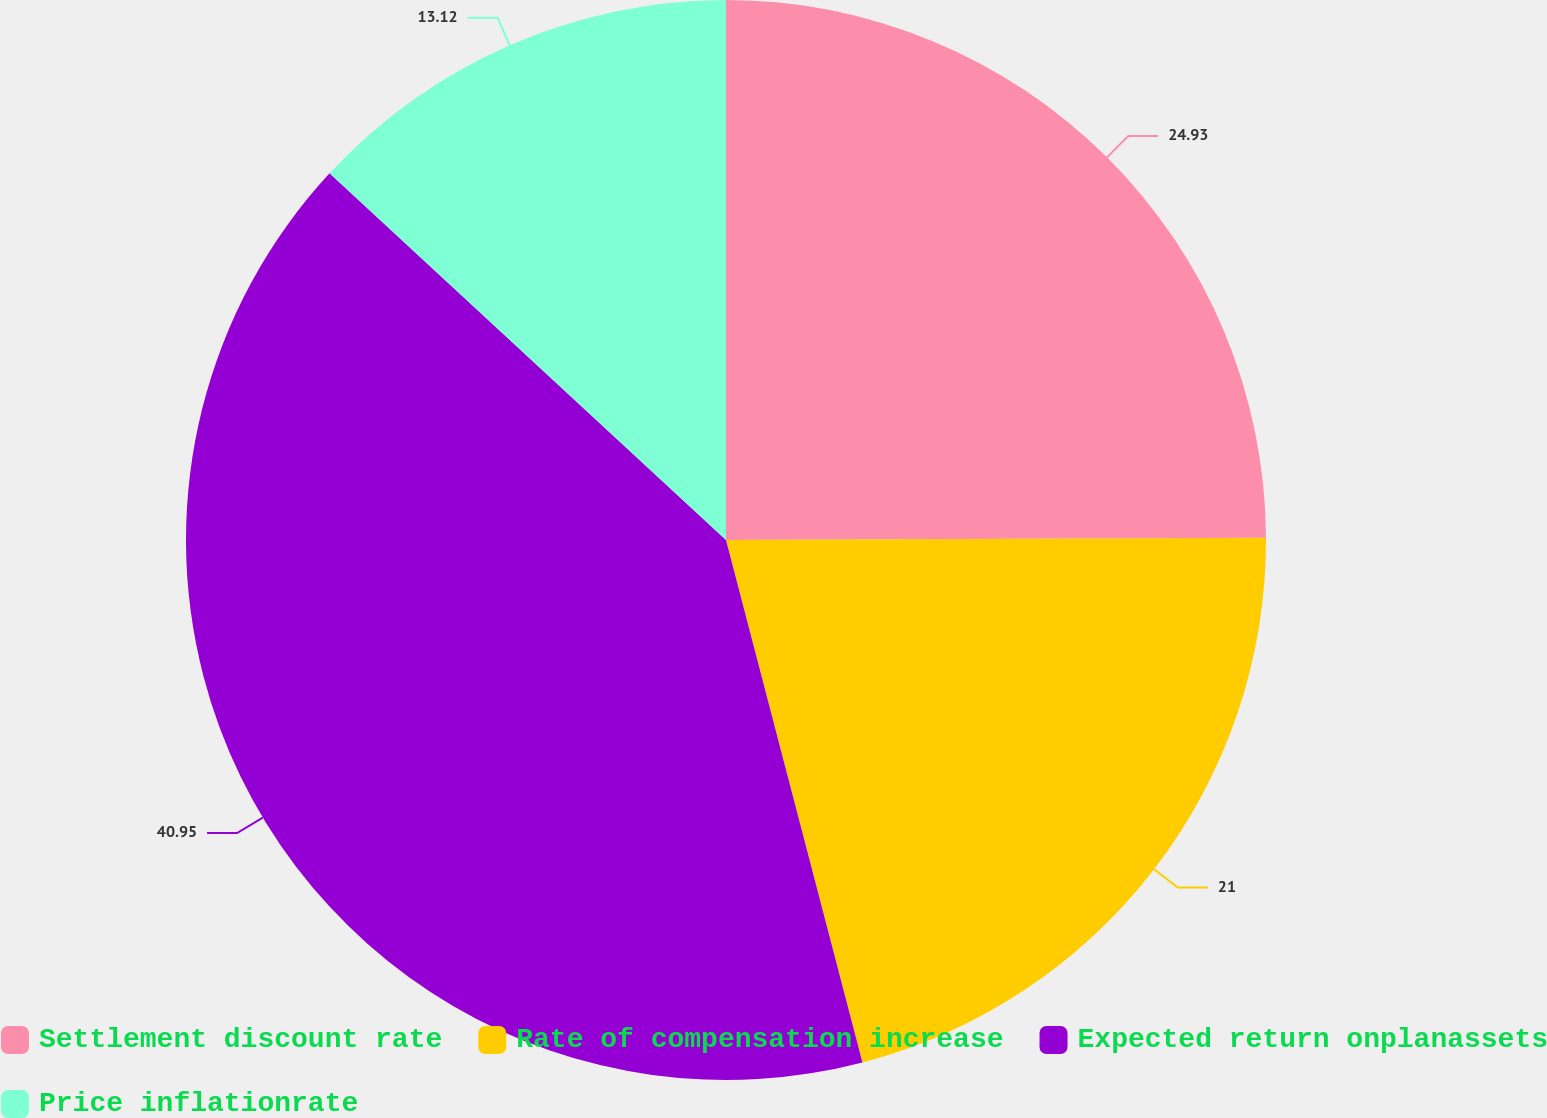Convert chart to OTSL. <chart><loc_0><loc_0><loc_500><loc_500><pie_chart><fcel>Settlement discount rate<fcel>Rate of compensation increase<fcel>Expected return onplanassets<fcel>Price inflationrate<nl><fcel>24.93%<fcel>21.0%<fcel>40.94%<fcel>13.12%<nl></chart> 